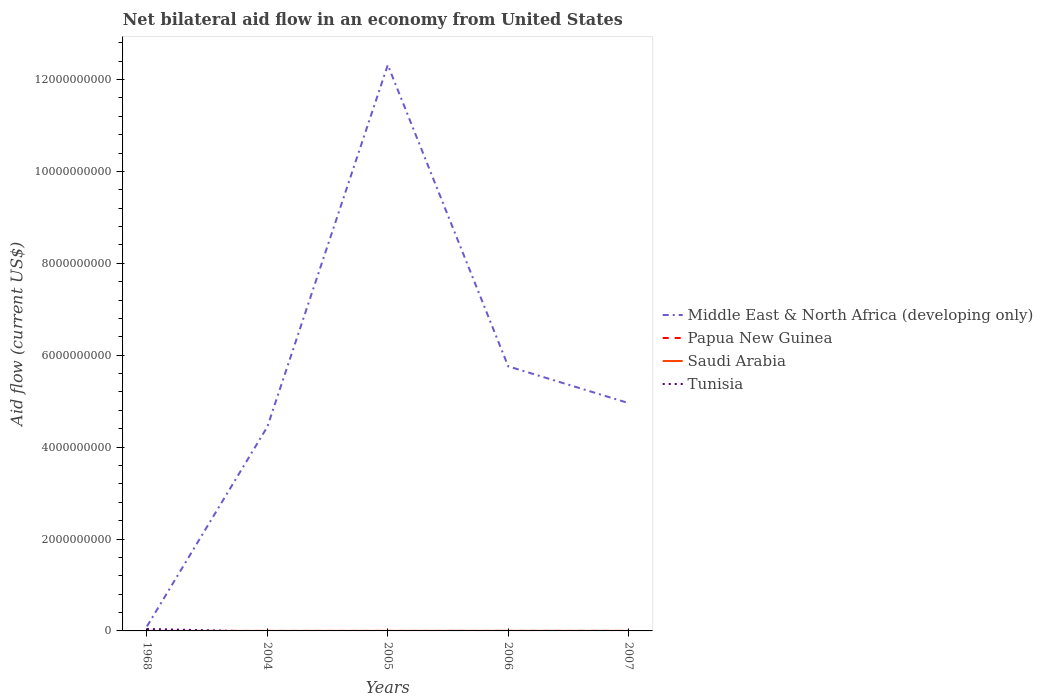How many different coloured lines are there?
Provide a short and direct response. 4. Is the number of lines equal to the number of legend labels?
Offer a terse response. No. Across all years, what is the maximum net bilateral aid flow in Tunisia?
Ensure brevity in your answer.  0. What is the total net bilateral aid flow in Papua New Guinea in the graph?
Make the answer very short. -6.00e+05. What is the difference between the highest and the second highest net bilateral aid flow in Papua New Guinea?
Give a very brief answer. 7.70e+05. How many lines are there?
Your answer should be very brief. 4. What is the difference between two consecutive major ticks on the Y-axis?
Your answer should be very brief. 2.00e+09. Are the values on the major ticks of Y-axis written in scientific E-notation?
Your response must be concise. No. Does the graph contain any zero values?
Make the answer very short. Yes. Where does the legend appear in the graph?
Offer a very short reply. Center right. How are the legend labels stacked?
Give a very brief answer. Vertical. What is the title of the graph?
Your answer should be compact. Net bilateral aid flow in an economy from United States. What is the Aid flow (current US$) of Middle East & North Africa (developing only) in 1968?
Make the answer very short. 9.87e+07. What is the Aid flow (current US$) in Papua New Guinea in 1968?
Your answer should be very brief. 10000. What is the Aid flow (current US$) in Tunisia in 1968?
Keep it short and to the point. 4.26e+07. What is the Aid flow (current US$) of Middle East & North Africa (developing only) in 2004?
Make the answer very short. 4.44e+09. What is the Aid flow (current US$) of Papua New Guinea in 2004?
Offer a very short reply. 1.10e+05. What is the Aid flow (current US$) in Middle East & North Africa (developing only) in 2005?
Offer a very short reply. 1.23e+1. What is the Aid flow (current US$) in Middle East & North Africa (developing only) in 2006?
Give a very brief answer. 5.76e+09. What is the Aid flow (current US$) in Saudi Arabia in 2006?
Offer a terse response. 6.80e+05. What is the Aid flow (current US$) of Middle East & North Africa (developing only) in 2007?
Ensure brevity in your answer.  4.96e+09. What is the Aid flow (current US$) of Papua New Guinea in 2007?
Offer a very short reply. 7.80e+05. What is the Aid flow (current US$) of Saudi Arabia in 2007?
Your answer should be compact. 1.50e+05. Across all years, what is the maximum Aid flow (current US$) in Middle East & North Africa (developing only)?
Ensure brevity in your answer.  1.23e+1. Across all years, what is the maximum Aid flow (current US$) of Papua New Guinea?
Make the answer very short. 7.80e+05. Across all years, what is the maximum Aid flow (current US$) of Saudi Arabia?
Ensure brevity in your answer.  6.80e+05. Across all years, what is the maximum Aid flow (current US$) of Tunisia?
Your answer should be very brief. 4.26e+07. Across all years, what is the minimum Aid flow (current US$) of Middle East & North Africa (developing only)?
Offer a terse response. 9.87e+07. Across all years, what is the minimum Aid flow (current US$) of Papua New Guinea?
Offer a very short reply. 10000. Across all years, what is the minimum Aid flow (current US$) in Saudi Arabia?
Your response must be concise. 6.00e+04. What is the total Aid flow (current US$) in Middle East & North Africa (developing only) in the graph?
Offer a terse response. 2.76e+1. What is the total Aid flow (current US$) of Papua New Guinea in the graph?
Keep it short and to the point. 1.11e+06. What is the total Aid flow (current US$) of Saudi Arabia in the graph?
Provide a succinct answer. 1.40e+06. What is the total Aid flow (current US$) in Tunisia in the graph?
Offer a very short reply. 4.26e+07. What is the difference between the Aid flow (current US$) in Middle East & North Africa (developing only) in 1968 and that in 2004?
Your answer should be very brief. -4.34e+09. What is the difference between the Aid flow (current US$) of Middle East & North Africa (developing only) in 1968 and that in 2005?
Offer a terse response. -1.22e+1. What is the difference between the Aid flow (current US$) of Saudi Arabia in 1968 and that in 2005?
Your answer should be very brief. -3.60e+05. What is the difference between the Aid flow (current US$) in Middle East & North Africa (developing only) in 1968 and that in 2006?
Ensure brevity in your answer.  -5.66e+09. What is the difference between the Aid flow (current US$) of Saudi Arabia in 1968 and that in 2006?
Make the answer very short. -6.20e+05. What is the difference between the Aid flow (current US$) in Middle East & North Africa (developing only) in 1968 and that in 2007?
Ensure brevity in your answer.  -4.86e+09. What is the difference between the Aid flow (current US$) of Papua New Guinea in 1968 and that in 2007?
Your response must be concise. -7.70e+05. What is the difference between the Aid flow (current US$) in Middle East & North Africa (developing only) in 2004 and that in 2005?
Offer a terse response. -7.87e+09. What is the difference between the Aid flow (current US$) of Papua New Guinea in 2004 and that in 2005?
Offer a very short reply. 8.00e+04. What is the difference between the Aid flow (current US$) of Saudi Arabia in 2004 and that in 2005?
Offer a terse response. -3.30e+05. What is the difference between the Aid flow (current US$) of Middle East & North Africa (developing only) in 2004 and that in 2006?
Your answer should be very brief. -1.32e+09. What is the difference between the Aid flow (current US$) in Saudi Arabia in 2004 and that in 2006?
Provide a succinct answer. -5.90e+05. What is the difference between the Aid flow (current US$) of Middle East & North Africa (developing only) in 2004 and that in 2007?
Ensure brevity in your answer.  -5.15e+08. What is the difference between the Aid flow (current US$) of Papua New Guinea in 2004 and that in 2007?
Provide a short and direct response. -6.70e+05. What is the difference between the Aid flow (current US$) in Middle East & North Africa (developing only) in 2005 and that in 2006?
Make the answer very short. 6.56e+09. What is the difference between the Aid flow (current US$) in Middle East & North Africa (developing only) in 2005 and that in 2007?
Your answer should be very brief. 7.36e+09. What is the difference between the Aid flow (current US$) of Papua New Guinea in 2005 and that in 2007?
Offer a very short reply. -7.50e+05. What is the difference between the Aid flow (current US$) of Saudi Arabia in 2005 and that in 2007?
Keep it short and to the point. 2.70e+05. What is the difference between the Aid flow (current US$) in Middle East & North Africa (developing only) in 2006 and that in 2007?
Your answer should be very brief. 8.00e+08. What is the difference between the Aid flow (current US$) in Papua New Guinea in 2006 and that in 2007?
Make the answer very short. -6.00e+05. What is the difference between the Aid flow (current US$) of Saudi Arabia in 2006 and that in 2007?
Provide a succinct answer. 5.30e+05. What is the difference between the Aid flow (current US$) of Middle East & North Africa (developing only) in 1968 and the Aid flow (current US$) of Papua New Guinea in 2004?
Make the answer very short. 9.86e+07. What is the difference between the Aid flow (current US$) of Middle East & North Africa (developing only) in 1968 and the Aid flow (current US$) of Saudi Arabia in 2004?
Offer a terse response. 9.86e+07. What is the difference between the Aid flow (current US$) of Middle East & North Africa (developing only) in 1968 and the Aid flow (current US$) of Papua New Guinea in 2005?
Make the answer very short. 9.86e+07. What is the difference between the Aid flow (current US$) of Middle East & North Africa (developing only) in 1968 and the Aid flow (current US$) of Saudi Arabia in 2005?
Your answer should be very brief. 9.82e+07. What is the difference between the Aid flow (current US$) in Papua New Guinea in 1968 and the Aid flow (current US$) in Saudi Arabia in 2005?
Your answer should be very brief. -4.10e+05. What is the difference between the Aid flow (current US$) in Middle East & North Africa (developing only) in 1968 and the Aid flow (current US$) in Papua New Guinea in 2006?
Offer a very short reply. 9.85e+07. What is the difference between the Aid flow (current US$) in Middle East & North Africa (developing only) in 1968 and the Aid flow (current US$) in Saudi Arabia in 2006?
Give a very brief answer. 9.80e+07. What is the difference between the Aid flow (current US$) of Papua New Guinea in 1968 and the Aid flow (current US$) of Saudi Arabia in 2006?
Offer a terse response. -6.70e+05. What is the difference between the Aid flow (current US$) in Middle East & North Africa (developing only) in 1968 and the Aid flow (current US$) in Papua New Guinea in 2007?
Make the answer very short. 9.79e+07. What is the difference between the Aid flow (current US$) of Middle East & North Africa (developing only) in 1968 and the Aid flow (current US$) of Saudi Arabia in 2007?
Provide a succinct answer. 9.85e+07. What is the difference between the Aid flow (current US$) in Papua New Guinea in 1968 and the Aid flow (current US$) in Saudi Arabia in 2007?
Provide a short and direct response. -1.40e+05. What is the difference between the Aid flow (current US$) of Middle East & North Africa (developing only) in 2004 and the Aid flow (current US$) of Papua New Guinea in 2005?
Provide a short and direct response. 4.44e+09. What is the difference between the Aid flow (current US$) of Middle East & North Africa (developing only) in 2004 and the Aid flow (current US$) of Saudi Arabia in 2005?
Make the answer very short. 4.44e+09. What is the difference between the Aid flow (current US$) of Papua New Guinea in 2004 and the Aid flow (current US$) of Saudi Arabia in 2005?
Provide a succinct answer. -3.10e+05. What is the difference between the Aid flow (current US$) in Middle East & North Africa (developing only) in 2004 and the Aid flow (current US$) in Papua New Guinea in 2006?
Offer a terse response. 4.44e+09. What is the difference between the Aid flow (current US$) in Middle East & North Africa (developing only) in 2004 and the Aid flow (current US$) in Saudi Arabia in 2006?
Your answer should be compact. 4.44e+09. What is the difference between the Aid flow (current US$) in Papua New Guinea in 2004 and the Aid flow (current US$) in Saudi Arabia in 2006?
Your answer should be compact. -5.70e+05. What is the difference between the Aid flow (current US$) of Middle East & North Africa (developing only) in 2004 and the Aid flow (current US$) of Papua New Guinea in 2007?
Your response must be concise. 4.44e+09. What is the difference between the Aid flow (current US$) in Middle East & North Africa (developing only) in 2004 and the Aid flow (current US$) in Saudi Arabia in 2007?
Provide a succinct answer. 4.44e+09. What is the difference between the Aid flow (current US$) of Papua New Guinea in 2004 and the Aid flow (current US$) of Saudi Arabia in 2007?
Ensure brevity in your answer.  -4.00e+04. What is the difference between the Aid flow (current US$) of Middle East & North Africa (developing only) in 2005 and the Aid flow (current US$) of Papua New Guinea in 2006?
Keep it short and to the point. 1.23e+1. What is the difference between the Aid flow (current US$) in Middle East & North Africa (developing only) in 2005 and the Aid flow (current US$) in Saudi Arabia in 2006?
Provide a succinct answer. 1.23e+1. What is the difference between the Aid flow (current US$) of Papua New Guinea in 2005 and the Aid flow (current US$) of Saudi Arabia in 2006?
Provide a short and direct response. -6.50e+05. What is the difference between the Aid flow (current US$) of Middle East & North Africa (developing only) in 2005 and the Aid flow (current US$) of Papua New Guinea in 2007?
Offer a terse response. 1.23e+1. What is the difference between the Aid flow (current US$) of Middle East & North Africa (developing only) in 2005 and the Aid flow (current US$) of Saudi Arabia in 2007?
Provide a short and direct response. 1.23e+1. What is the difference between the Aid flow (current US$) in Middle East & North Africa (developing only) in 2006 and the Aid flow (current US$) in Papua New Guinea in 2007?
Your answer should be very brief. 5.76e+09. What is the difference between the Aid flow (current US$) in Middle East & North Africa (developing only) in 2006 and the Aid flow (current US$) in Saudi Arabia in 2007?
Provide a succinct answer. 5.76e+09. What is the difference between the Aid flow (current US$) of Papua New Guinea in 2006 and the Aid flow (current US$) of Saudi Arabia in 2007?
Keep it short and to the point. 3.00e+04. What is the average Aid flow (current US$) of Middle East & North Africa (developing only) per year?
Your answer should be very brief. 5.52e+09. What is the average Aid flow (current US$) of Papua New Guinea per year?
Keep it short and to the point. 2.22e+05. What is the average Aid flow (current US$) in Tunisia per year?
Make the answer very short. 8.52e+06. In the year 1968, what is the difference between the Aid flow (current US$) in Middle East & North Africa (developing only) and Aid flow (current US$) in Papua New Guinea?
Ensure brevity in your answer.  9.87e+07. In the year 1968, what is the difference between the Aid flow (current US$) in Middle East & North Africa (developing only) and Aid flow (current US$) in Saudi Arabia?
Make the answer very short. 9.86e+07. In the year 1968, what is the difference between the Aid flow (current US$) in Middle East & North Africa (developing only) and Aid flow (current US$) in Tunisia?
Your response must be concise. 5.60e+07. In the year 1968, what is the difference between the Aid flow (current US$) in Papua New Guinea and Aid flow (current US$) in Saudi Arabia?
Give a very brief answer. -5.00e+04. In the year 1968, what is the difference between the Aid flow (current US$) of Papua New Guinea and Aid flow (current US$) of Tunisia?
Offer a very short reply. -4.26e+07. In the year 1968, what is the difference between the Aid flow (current US$) in Saudi Arabia and Aid flow (current US$) in Tunisia?
Your answer should be very brief. -4.26e+07. In the year 2004, what is the difference between the Aid flow (current US$) of Middle East & North Africa (developing only) and Aid flow (current US$) of Papua New Guinea?
Offer a very short reply. 4.44e+09. In the year 2004, what is the difference between the Aid flow (current US$) of Middle East & North Africa (developing only) and Aid flow (current US$) of Saudi Arabia?
Your response must be concise. 4.44e+09. In the year 2005, what is the difference between the Aid flow (current US$) of Middle East & North Africa (developing only) and Aid flow (current US$) of Papua New Guinea?
Keep it short and to the point. 1.23e+1. In the year 2005, what is the difference between the Aid flow (current US$) in Middle East & North Africa (developing only) and Aid flow (current US$) in Saudi Arabia?
Your response must be concise. 1.23e+1. In the year 2005, what is the difference between the Aid flow (current US$) in Papua New Guinea and Aid flow (current US$) in Saudi Arabia?
Ensure brevity in your answer.  -3.90e+05. In the year 2006, what is the difference between the Aid flow (current US$) in Middle East & North Africa (developing only) and Aid flow (current US$) in Papua New Guinea?
Ensure brevity in your answer.  5.76e+09. In the year 2006, what is the difference between the Aid flow (current US$) of Middle East & North Africa (developing only) and Aid flow (current US$) of Saudi Arabia?
Provide a succinct answer. 5.76e+09. In the year 2006, what is the difference between the Aid flow (current US$) of Papua New Guinea and Aid flow (current US$) of Saudi Arabia?
Provide a short and direct response. -5.00e+05. In the year 2007, what is the difference between the Aid flow (current US$) of Middle East & North Africa (developing only) and Aid flow (current US$) of Papua New Guinea?
Your answer should be compact. 4.96e+09. In the year 2007, what is the difference between the Aid flow (current US$) in Middle East & North Africa (developing only) and Aid flow (current US$) in Saudi Arabia?
Provide a short and direct response. 4.96e+09. In the year 2007, what is the difference between the Aid flow (current US$) in Papua New Guinea and Aid flow (current US$) in Saudi Arabia?
Your response must be concise. 6.30e+05. What is the ratio of the Aid flow (current US$) of Middle East & North Africa (developing only) in 1968 to that in 2004?
Ensure brevity in your answer.  0.02. What is the ratio of the Aid flow (current US$) in Papua New Guinea in 1968 to that in 2004?
Give a very brief answer. 0.09. What is the ratio of the Aid flow (current US$) of Saudi Arabia in 1968 to that in 2004?
Offer a terse response. 0.67. What is the ratio of the Aid flow (current US$) in Middle East & North Africa (developing only) in 1968 to that in 2005?
Provide a short and direct response. 0.01. What is the ratio of the Aid flow (current US$) of Saudi Arabia in 1968 to that in 2005?
Give a very brief answer. 0.14. What is the ratio of the Aid flow (current US$) of Middle East & North Africa (developing only) in 1968 to that in 2006?
Provide a short and direct response. 0.02. What is the ratio of the Aid flow (current US$) in Papua New Guinea in 1968 to that in 2006?
Offer a terse response. 0.06. What is the ratio of the Aid flow (current US$) in Saudi Arabia in 1968 to that in 2006?
Provide a succinct answer. 0.09. What is the ratio of the Aid flow (current US$) in Middle East & North Africa (developing only) in 1968 to that in 2007?
Provide a succinct answer. 0.02. What is the ratio of the Aid flow (current US$) in Papua New Guinea in 1968 to that in 2007?
Keep it short and to the point. 0.01. What is the ratio of the Aid flow (current US$) of Middle East & North Africa (developing only) in 2004 to that in 2005?
Offer a very short reply. 0.36. What is the ratio of the Aid flow (current US$) in Papua New Guinea in 2004 to that in 2005?
Make the answer very short. 3.67. What is the ratio of the Aid flow (current US$) in Saudi Arabia in 2004 to that in 2005?
Keep it short and to the point. 0.21. What is the ratio of the Aid flow (current US$) in Middle East & North Africa (developing only) in 2004 to that in 2006?
Offer a very short reply. 0.77. What is the ratio of the Aid flow (current US$) in Papua New Guinea in 2004 to that in 2006?
Offer a very short reply. 0.61. What is the ratio of the Aid flow (current US$) of Saudi Arabia in 2004 to that in 2006?
Make the answer very short. 0.13. What is the ratio of the Aid flow (current US$) in Middle East & North Africa (developing only) in 2004 to that in 2007?
Your answer should be compact. 0.9. What is the ratio of the Aid flow (current US$) in Papua New Guinea in 2004 to that in 2007?
Your answer should be compact. 0.14. What is the ratio of the Aid flow (current US$) in Saudi Arabia in 2004 to that in 2007?
Provide a succinct answer. 0.6. What is the ratio of the Aid flow (current US$) in Middle East & North Africa (developing only) in 2005 to that in 2006?
Provide a succinct answer. 2.14. What is the ratio of the Aid flow (current US$) in Saudi Arabia in 2005 to that in 2006?
Provide a succinct answer. 0.62. What is the ratio of the Aid flow (current US$) of Middle East & North Africa (developing only) in 2005 to that in 2007?
Your answer should be compact. 2.48. What is the ratio of the Aid flow (current US$) in Papua New Guinea in 2005 to that in 2007?
Your answer should be compact. 0.04. What is the ratio of the Aid flow (current US$) of Saudi Arabia in 2005 to that in 2007?
Give a very brief answer. 2.8. What is the ratio of the Aid flow (current US$) of Middle East & North Africa (developing only) in 2006 to that in 2007?
Your response must be concise. 1.16. What is the ratio of the Aid flow (current US$) of Papua New Guinea in 2006 to that in 2007?
Give a very brief answer. 0.23. What is the ratio of the Aid flow (current US$) of Saudi Arabia in 2006 to that in 2007?
Keep it short and to the point. 4.53. What is the difference between the highest and the second highest Aid flow (current US$) in Middle East & North Africa (developing only)?
Ensure brevity in your answer.  6.56e+09. What is the difference between the highest and the second highest Aid flow (current US$) in Papua New Guinea?
Give a very brief answer. 6.00e+05. What is the difference between the highest and the second highest Aid flow (current US$) of Saudi Arabia?
Make the answer very short. 2.60e+05. What is the difference between the highest and the lowest Aid flow (current US$) of Middle East & North Africa (developing only)?
Make the answer very short. 1.22e+1. What is the difference between the highest and the lowest Aid flow (current US$) in Papua New Guinea?
Give a very brief answer. 7.70e+05. What is the difference between the highest and the lowest Aid flow (current US$) of Saudi Arabia?
Keep it short and to the point. 6.20e+05. What is the difference between the highest and the lowest Aid flow (current US$) in Tunisia?
Provide a short and direct response. 4.26e+07. 